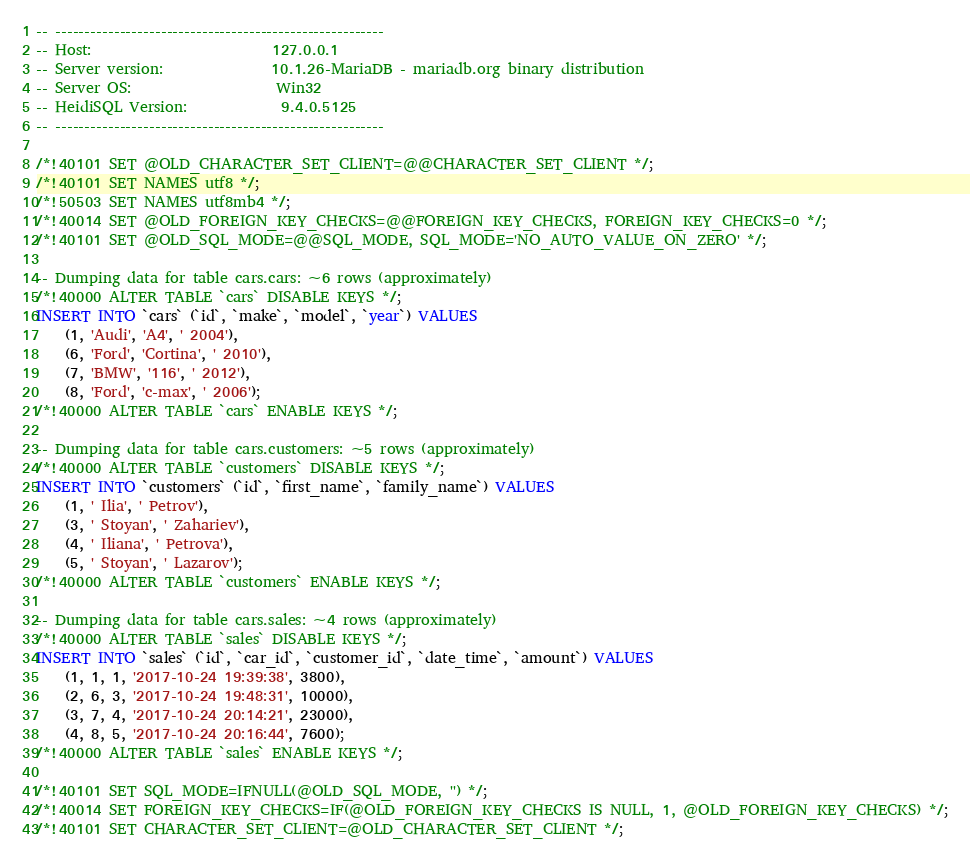<code> <loc_0><loc_0><loc_500><loc_500><_SQL_>-- --------------------------------------------------------
-- Host:                         127.0.0.1
-- Server version:               10.1.26-MariaDB - mariadb.org binary distribution
-- Server OS:                    Win32
-- HeidiSQL Version:             9.4.0.5125
-- --------------------------------------------------------

/*!40101 SET @OLD_CHARACTER_SET_CLIENT=@@CHARACTER_SET_CLIENT */;
/*!40101 SET NAMES utf8 */;
/*!50503 SET NAMES utf8mb4 */;
/*!40014 SET @OLD_FOREIGN_KEY_CHECKS=@@FOREIGN_KEY_CHECKS, FOREIGN_KEY_CHECKS=0 */;
/*!40101 SET @OLD_SQL_MODE=@@SQL_MODE, SQL_MODE='NO_AUTO_VALUE_ON_ZERO' */;

-- Dumping data for table cars.cars: ~6 rows (approximately)
/*!40000 ALTER TABLE `cars` DISABLE KEYS */;
INSERT INTO `cars` (`id`, `make`, `model`, `year`) VALUES
	(1, 'Audi', 'A4', ' 2004'),
	(6, 'Ford', 'Cortina', ' 2010'),
	(7, 'BMW', '116', ' 2012'),
	(8, 'Ford', 'c-max', ' 2006');
/*!40000 ALTER TABLE `cars` ENABLE KEYS */;

-- Dumping data for table cars.customers: ~5 rows (approximately)
/*!40000 ALTER TABLE `customers` DISABLE KEYS */;
INSERT INTO `customers` (`id`, `first_name`, `family_name`) VALUES
	(1, ' Ilia', ' Petrov'),
	(3, ' Stoyan', ' Zahariev'),
	(4, ' Iliana', ' Petrova'),
	(5, ' Stoyan', ' Lazarov');
/*!40000 ALTER TABLE `customers` ENABLE KEYS */;

-- Dumping data for table cars.sales: ~4 rows (approximately)
/*!40000 ALTER TABLE `sales` DISABLE KEYS */;
INSERT INTO `sales` (`id`, `car_id`, `customer_id`, `date_time`, `amount`) VALUES
	(1, 1, 1, '2017-10-24 19:39:38', 3800),
	(2, 6, 3, '2017-10-24 19:48:31', 10000),
	(3, 7, 4, '2017-10-24 20:14:21', 23000),
	(4, 8, 5, '2017-10-24 20:16:44', 7600);
/*!40000 ALTER TABLE `sales` ENABLE KEYS */;

/*!40101 SET SQL_MODE=IFNULL(@OLD_SQL_MODE, '') */;
/*!40014 SET FOREIGN_KEY_CHECKS=IF(@OLD_FOREIGN_KEY_CHECKS IS NULL, 1, @OLD_FOREIGN_KEY_CHECKS) */;
/*!40101 SET CHARACTER_SET_CLIENT=@OLD_CHARACTER_SET_CLIENT */;
</code> 